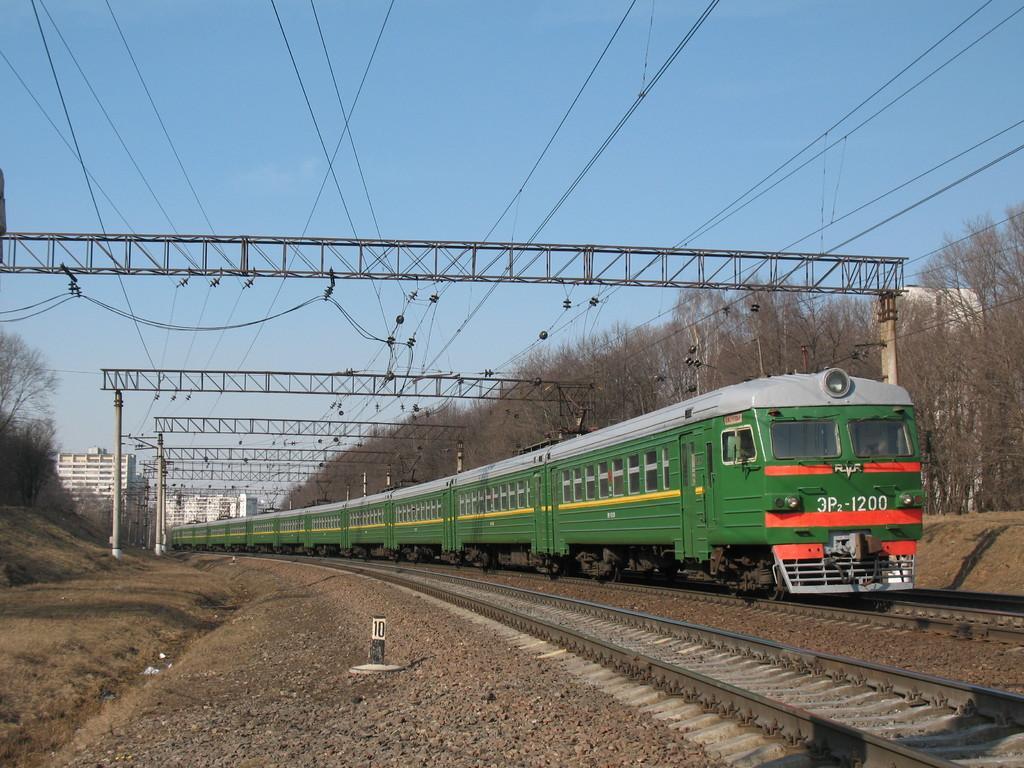Describe this image in one or two sentences. In this image there is a train on the railway track. In the background of the image there are metal rods, wires. There are buildings, trees. On top of the image there is sky. 